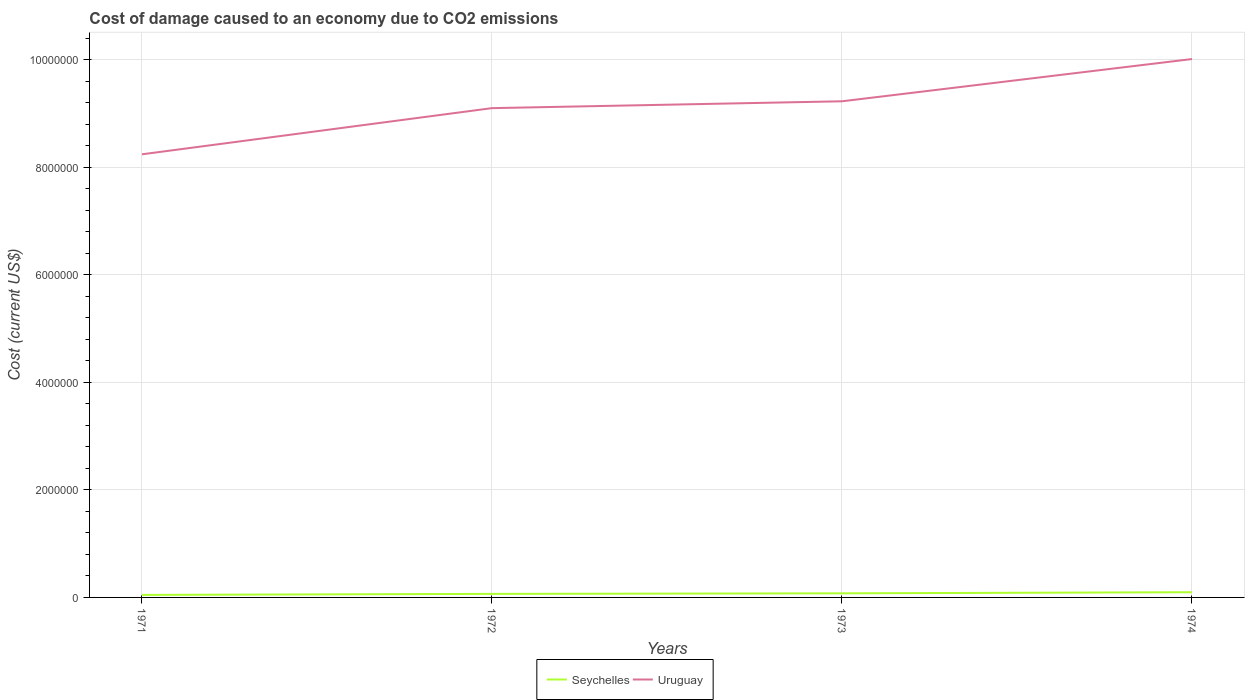Does the line corresponding to Uruguay intersect with the line corresponding to Seychelles?
Provide a succinct answer. No. Across all years, what is the maximum cost of damage caused due to CO2 emissisons in Uruguay?
Keep it short and to the point. 8.24e+06. What is the total cost of damage caused due to CO2 emissisons in Uruguay in the graph?
Offer a very short reply. -7.86e+05. What is the difference between the highest and the second highest cost of damage caused due to CO2 emissisons in Uruguay?
Provide a short and direct response. 1.77e+06. Is the cost of damage caused due to CO2 emissisons in Seychelles strictly greater than the cost of damage caused due to CO2 emissisons in Uruguay over the years?
Provide a short and direct response. Yes. How many years are there in the graph?
Offer a very short reply. 4. What is the difference between two consecutive major ticks on the Y-axis?
Offer a terse response. 2.00e+06. Where does the legend appear in the graph?
Provide a short and direct response. Bottom center. What is the title of the graph?
Your answer should be compact. Cost of damage caused to an economy due to CO2 emissions. Does "Uzbekistan" appear as one of the legend labels in the graph?
Provide a short and direct response. No. What is the label or title of the X-axis?
Your answer should be very brief. Years. What is the label or title of the Y-axis?
Ensure brevity in your answer.  Cost (current US$). What is the Cost (current US$) of Seychelles in 1971?
Make the answer very short. 4.68e+04. What is the Cost (current US$) of Uruguay in 1971?
Offer a terse response. 8.24e+06. What is the Cost (current US$) of Seychelles in 1972?
Keep it short and to the point. 6.59e+04. What is the Cost (current US$) in Uruguay in 1972?
Offer a terse response. 9.10e+06. What is the Cost (current US$) in Seychelles in 1973?
Provide a succinct answer. 7.62e+04. What is the Cost (current US$) of Uruguay in 1973?
Offer a very short reply. 9.23e+06. What is the Cost (current US$) of Seychelles in 1974?
Ensure brevity in your answer.  9.69e+04. What is the Cost (current US$) in Uruguay in 1974?
Offer a terse response. 1.00e+07. Across all years, what is the maximum Cost (current US$) in Seychelles?
Your response must be concise. 9.69e+04. Across all years, what is the maximum Cost (current US$) in Uruguay?
Provide a succinct answer. 1.00e+07. Across all years, what is the minimum Cost (current US$) in Seychelles?
Your response must be concise. 4.68e+04. Across all years, what is the minimum Cost (current US$) in Uruguay?
Give a very brief answer. 8.24e+06. What is the total Cost (current US$) of Seychelles in the graph?
Give a very brief answer. 2.86e+05. What is the total Cost (current US$) of Uruguay in the graph?
Your response must be concise. 3.66e+07. What is the difference between the Cost (current US$) in Seychelles in 1971 and that in 1972?
Make the answer very short. -1.91e+04. What is the difference between the Cost (current US$) in Uruguay in 1971 and that in 1972?
Your answer should be very brief. -8.59e+05. What is the difference between the Cost (current US$) of Seychelles in 1971 and that in 1973?
Provide a succinct answer. -2.93e+04. What is the difference between the Cost (current US$) of Uruguay in 1971 and that in 1973?
Your answer should be very brief. -9.86e+05. What is the difference between the Cost (current US$) in Seychelles in 1971 and that in 1974?
Your response must be concise. -5.01e+04. What is the difference between the Cost (current US$) in Uruguay in 1971 and that in 1974?
Your answer should be compact. -1.77e+06. What is the difference between the Cost (current US$) in Seychelles in 1972 and that in 1973?
Your answer should be compact. -1.03e+04. What is the difference between the Cost (current US$) of Uruguay in 1972 and that in 1973?
Provide a succinct answer. -1.28e+05. What is the difference between the Cost (current US$) in Seychelles in 1972 and that in 1974?
Give a very brief answer. -3.10e+04. What is the difference between the Cost (current US$) in Uruguay in 1972 and that in 1974?
Offer a very short reply. -9.13e+05. What is the difference between the Cost (current US$) of Seychelles in 1973 and that in 1974?
Ensure brevity in your answer.  -2.07e+04. What is the difference between the Cost (current US$) in Uruguay in 1973 and that in 1974?
Your response must be concise. -7.86e+05. What is the difference between the Cost (current US$) in Seychelles in 1971 and the Cost (current US$) in Uruguay in 1972?
Your response must be concise. -9.05e+06. What is the difference between the Cost (current US$) of Seychelles in 1971 and the Cost (current US$) of Uruguay in 1973?
Your response must be concise. -9.18e+06. What is the difference between the Cost (current US$) in Seychelles in 1971 and the Cost (current US$) in Uruguay in 1974?
Make the answer very short. -9.97e+06. What is the difference between the Cost (current US$) of Seychelles in 1972 and the Cost (current US$) of Uruguay in 1973?
Provide a short and direct response. -9.16e+06. What is the difference between the Cost (current US$) in Seychelles in 1972 and the Cost (current US$) in Uruguay in 1974?
Ensure brevity in your answer.  -9.95e+06. What is the difference between the Cost (current US$) of Seychelles in 1973 and the Cost (current US$) of Uruguay in 1974?
Ensure brevity in your answer.  -9.94e+06. What is the average Cost (current US$) of Seychelles per year?
Your answer should be very brief. 7.15e+04. What is the average Cost (current US$) of Uruguay per year?
Your answer should be compact. 9.15e+06. In the year 1971, what is the difference between the Cost (current US$) in Seychelles and Cost (current US$) in Uruguay?
Ensure brevity in your answer.  -8.20e+06. In the year 1972, what is the difference between the Cost (current US$) in Seychelles and Cost (current US$) in Uruguay?
Keep it short and to the point. -9.04e+06. In the year 1973, what is the difference between the Cost (current US$) in Seychelles and Cost (current US$) in Uruguay?
Your response must be concise. -9.15e+06. In the year 1974, what is the difference between the Cost (current US$) of Seychelles and Cost (current US$) of Uruguay?
Your answer should be compact. -9.92e+06. What is the ratio of the Cost (current US$) of Seychelles in 1971 to that in 1972?
Provide a succinct answer. 0.71. What is the ratio of the Cost (current US$) in Uruguay in 1971 to that in 1972?
Offer a terse response. 0.91. What is the ratio of the Cost (current US$) in Seychelles in 1971 to that in 1973?
Keep it short and to the point. 0.61. What is the ratio of the Cost (current US$) in Uruguay in 1971 to that in 1973?
Provide a succinct answer. 0.89. What is the ratio of the Cost (current US$) of Seychelles in 1971 to that in 1974?
Keep it short and to the point. 0.48. What is the ratio of the Cost (current US$) in Uruguay in 1971 to that in 1974?
Your response must be concise. 0.82. What is the ratio of the Cost (current US$) in Seychelles in 1972 to that in 1973?
Keep it short and to the point. 0.87. What is the ratio of the Cost (current US$) in Uruguay in 1972 to that in 1973?
Provide a succinct answer. 0.99. What is the ratio of the Cost (current US$) of Seychelles in 1972 to that in 1974?
Keep it short and to the point. 0.68. What is the ratio of the Cost (current US$) of Uruguay in 1972 to that in 1974?
Ensure brevity in your answer.  0.91. What is the ratio of the Cost (current US$) of Seychelles in 1973 to that in 1974?
Offer a terse response. 0.79. What is the ratio of the Cost (current US$) in Uruguay in 1973 to that in 1974?
Offer a very short reply. 0.92. What is the difference between the highest and the second highest Cost (current US$) of Seychelles?
Provide a succinct answer. 2.07e+04. What is the difference between the highest and the second highest Cost (current US$) in Uruguay?
Offer a terse response. 7.86e+05. What is the difference between the highest and the lowest Cost (current US$) in Seychelles?
Provide a short and direct response. 5.01e+04. What is the difference between the highest and the lowest Cost (current US$) in Uruguay?
Your answer should be compact. 1.77e+06. 